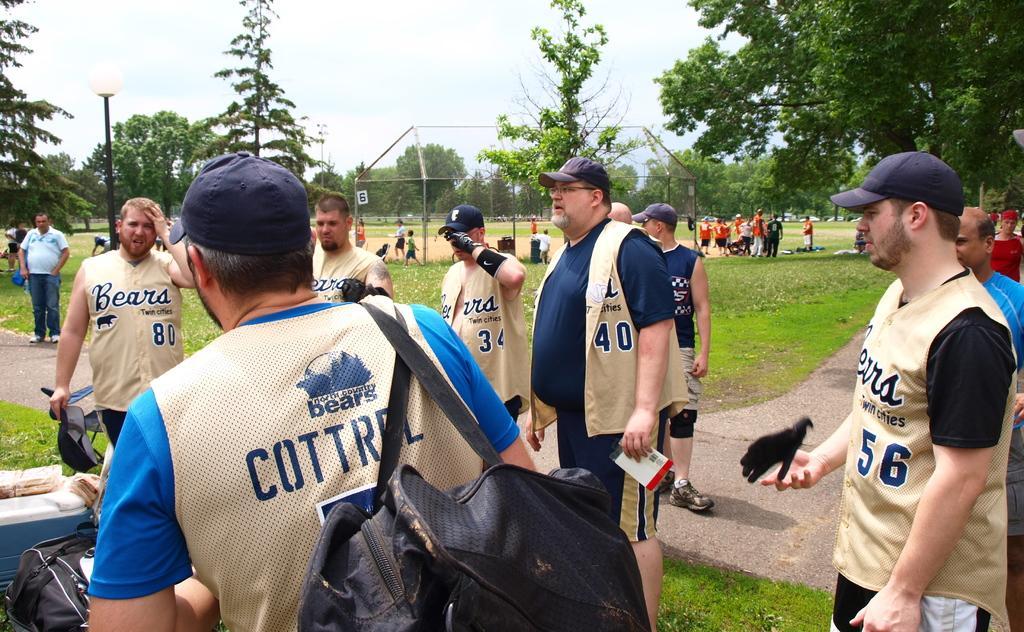Describe this image in one or two sentences. In this image I can see the group of people with the dresses and few people with the caps. I can see one person with the bag. To the left I can see an another bag and few objects on the ground. In the background I can see more people, pole and many trees. In the background I can see the sky. 